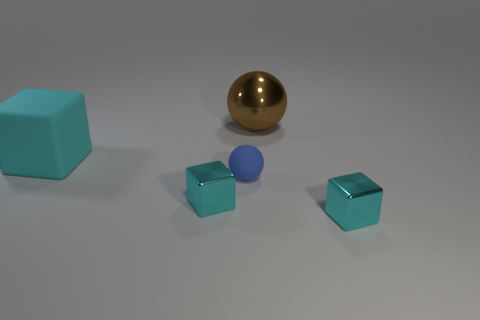Subtract all cyan blocks. How many were subtracted if there are1cyan blocks left? 2 Add 3 purple spheres. How many objects exist? 8 Subtract all spheres. How many objects are left? 3 Add 3 large brown shiny objects. How many large brown shiny objects are left? 4 Add 4 small matte blocks. How many small matte blocks exist? 4 Subtract 1 blue balls. How many objects are left? 4 Subtract all big cyan rubber cubes. Subtract all tiny cyan metal blocks. How many objects are left? 2 